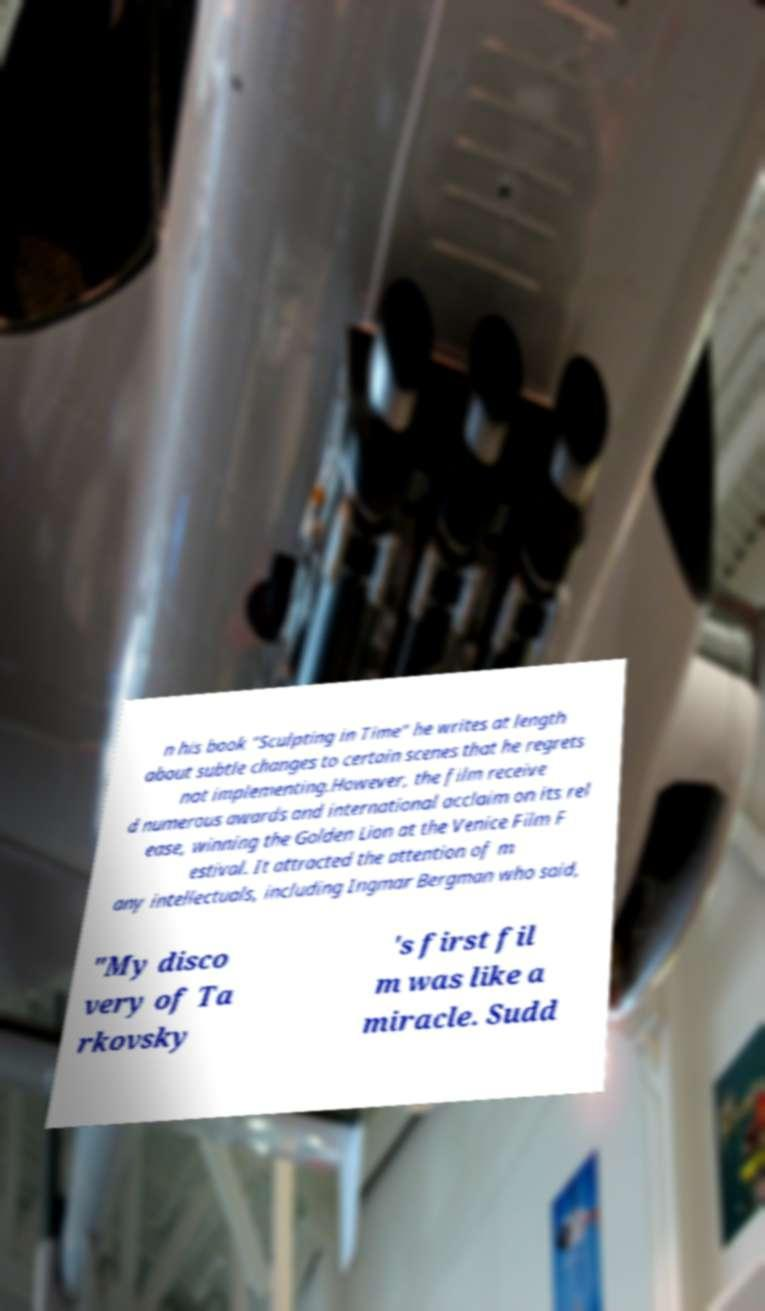Could you assist in decoding the text presented in this image and type it out clearly? n his book "Sculpting in Time" he writes at length about subtle changes to certain scenes that he regrets not implementing.However, the film receive d numerous awards and international acclaim on its rel ease, winning the Golden Lion at the Venice Film F estival. It attracted the attention of m any intellectuals, including Ingmar Bergman who said, "My disco very of Ta rkovsky 's first fil m was like a miracle. Sudd 